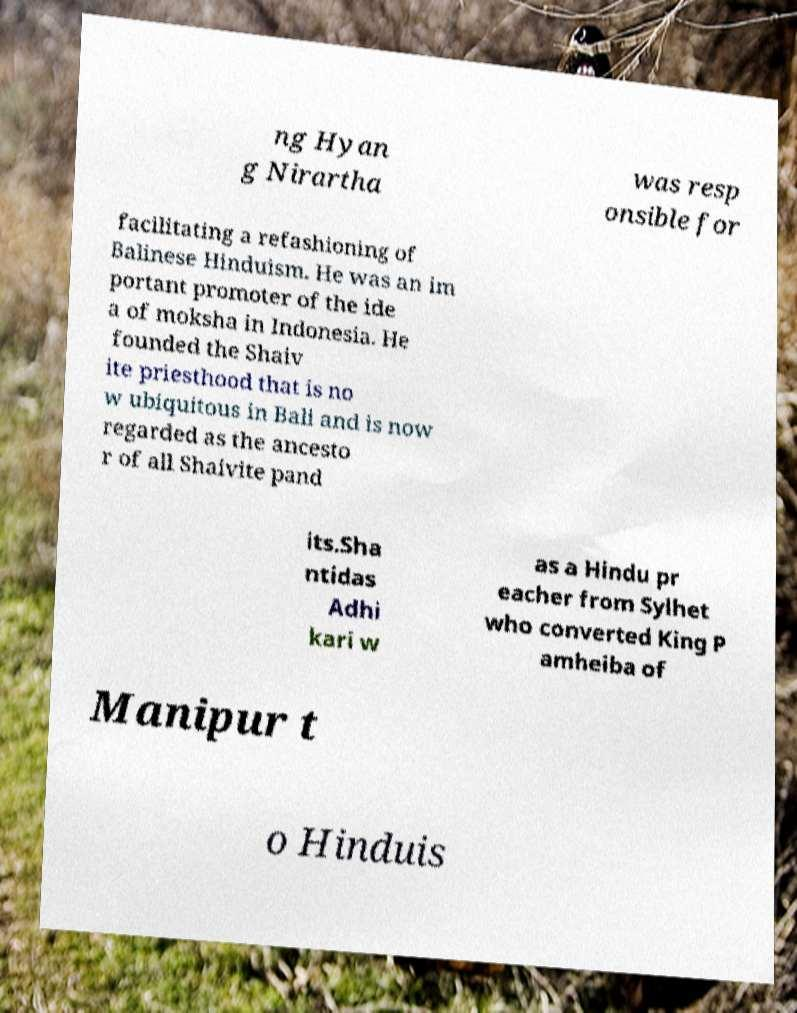What messages or text are displayed in this image? I need them in a readable, typed format. ng Hyan g Nirartha was resp onsible for facilitating a refashioning of Balinese Hinduism. He was an im portant promoter of the ide a of moksha in Indonesia. He founded the Shaiv ite priesthood that is no w ubiquitous in Bali and is now regarded as the ancesto r of all Shaivite pand its.Sha ntidas Adhi kari w as a Hindu pr eacher from Sylhet who converted King P amheiba of Manipur t o Hinduis 